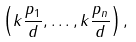<formula> <loc_0><loc_0><loc_500><loc_500>\left ( k { \frac { p _ { 1 } } { d } } , \dots , k { \frac { p _ { n } } { d } } \right ) ,</formula> 